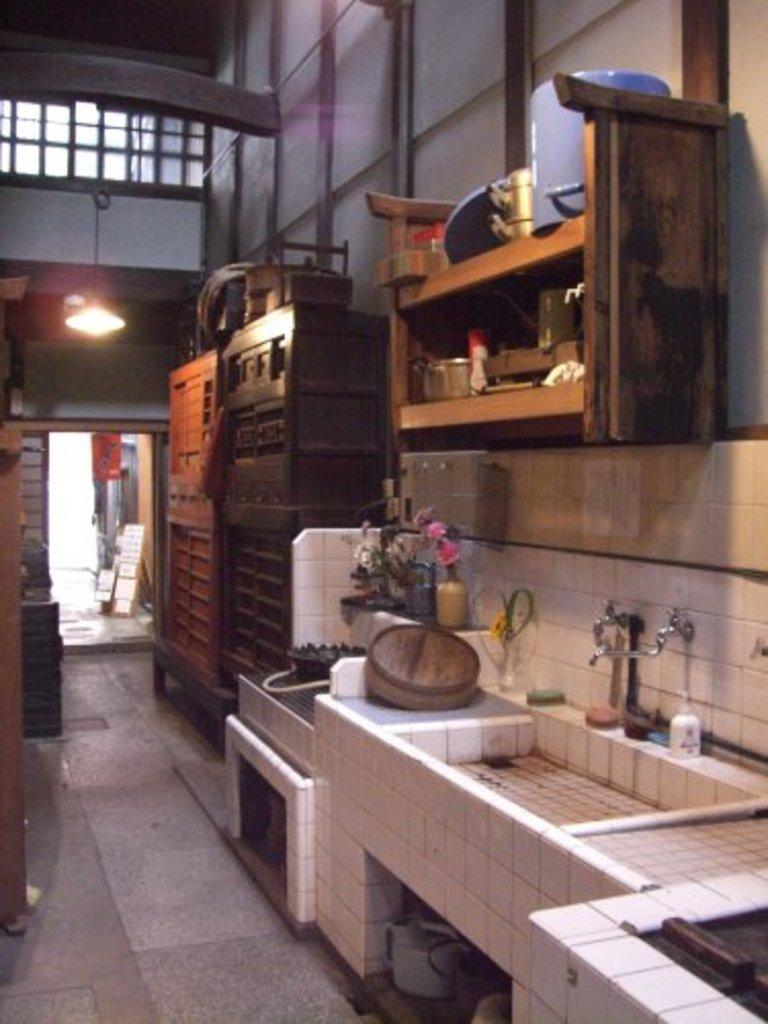What is the main object in the image? There is a wash basin in the image. What other objects can be seen near the wash basin? There is a wooden drawer, a flower pot, and taps visible in the image. What type of furniture is present in the image? There is a wooden table in the image. What lighting source is present in the image? There is a light in the image. What architectural features can be seen in the image? There is a window and a door in the image. How many rabbits are hopping around the wash basin in the image? There are no rabbits present in the image. What time does the clock show on the wall in the image? There is no clock present in the image. 